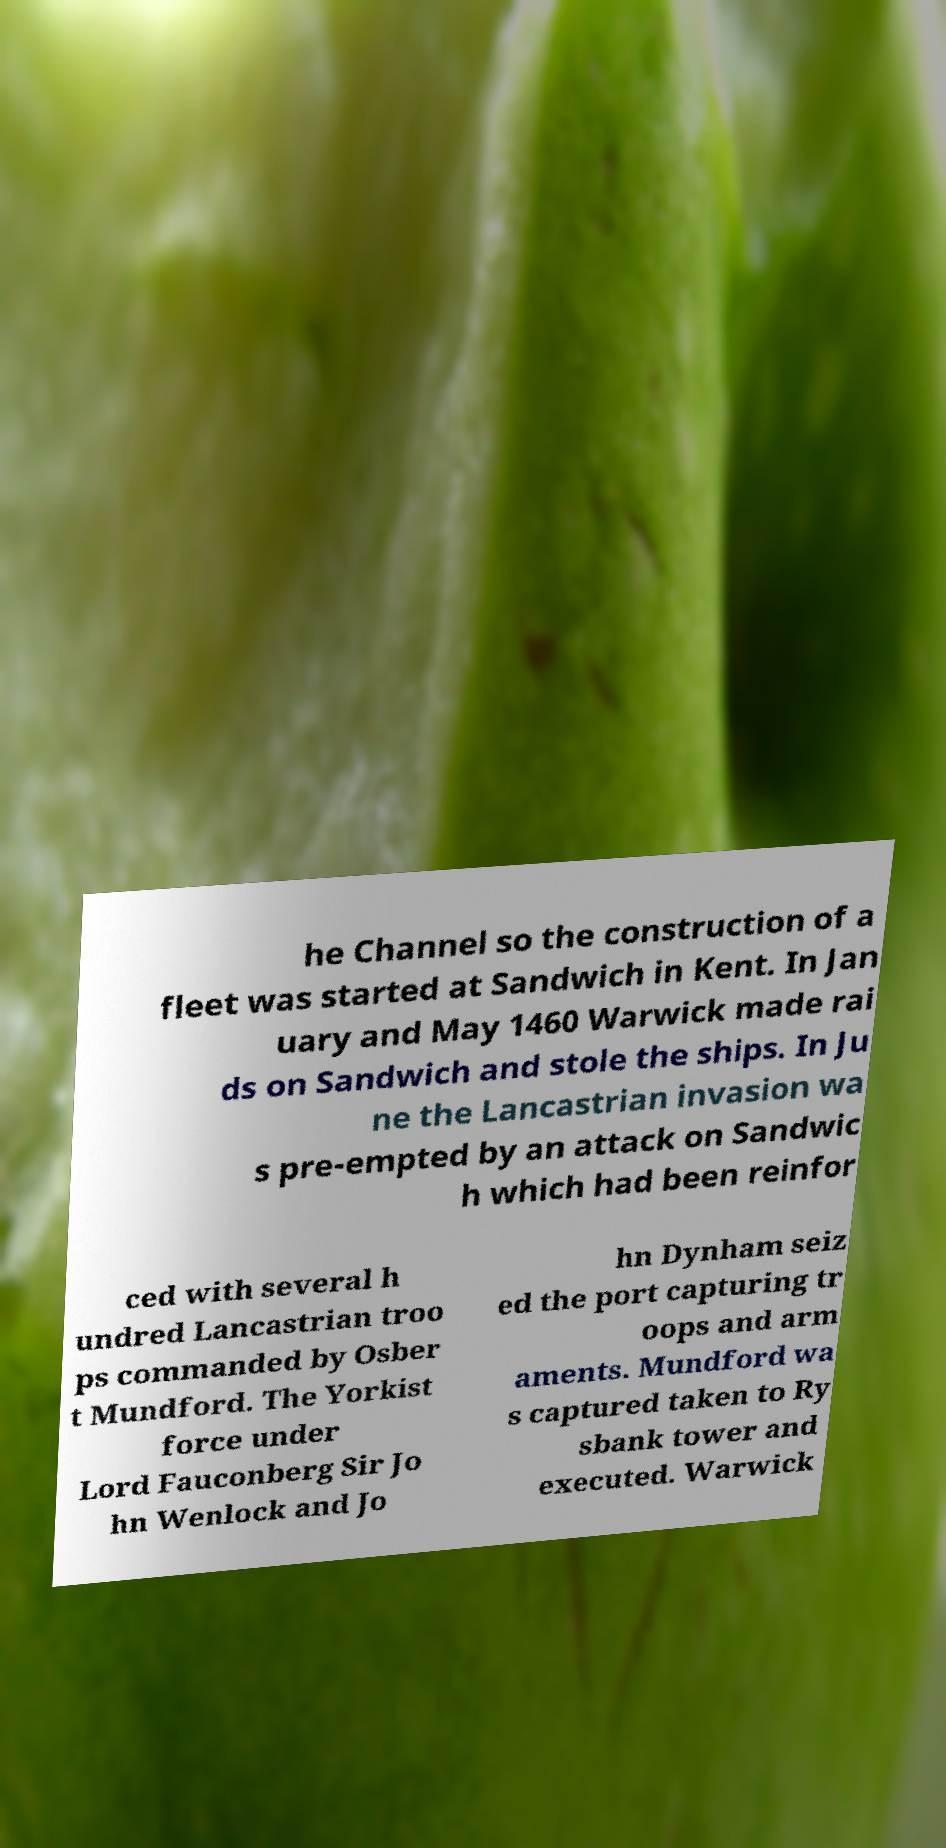What messages or text are displayed in this image? I need them in a readable, typed format. he Channel so the construction of a fleet was started at Sandwich in Kent. In Jan uary and May 1460 Warwick made rai ds on Sandwich and stole the ships. In Ju ne the Lancastrian invasion wa s pre-empted by an attack on Sandwic h which had been reinfor ced with several h undred Lancastrian troo ps commanded by Osber t Mundford. The Yorkist force under Lord Fauconberg Sir Jo hn Wenlock and Jo hn Dynham seiz ed the port capturing tr oops and arm aments. Mundford wa s captured taken to Ry sbank tower and executed. Warwick 